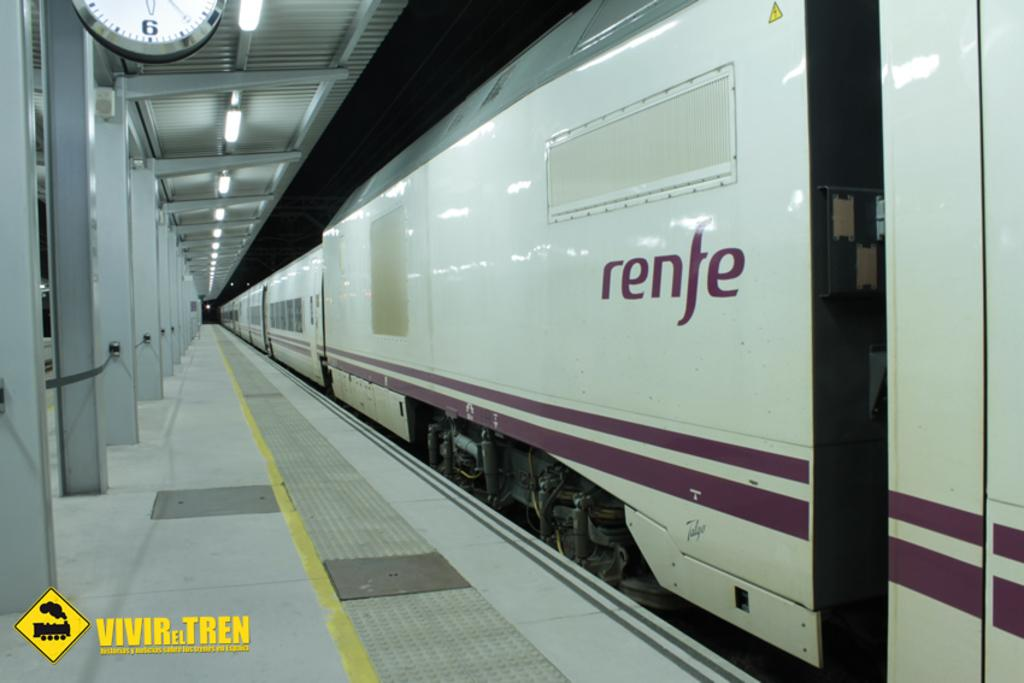<image>
Present a compact description of the photo's key features. A train that says renfe on the side is stopped at the station. 